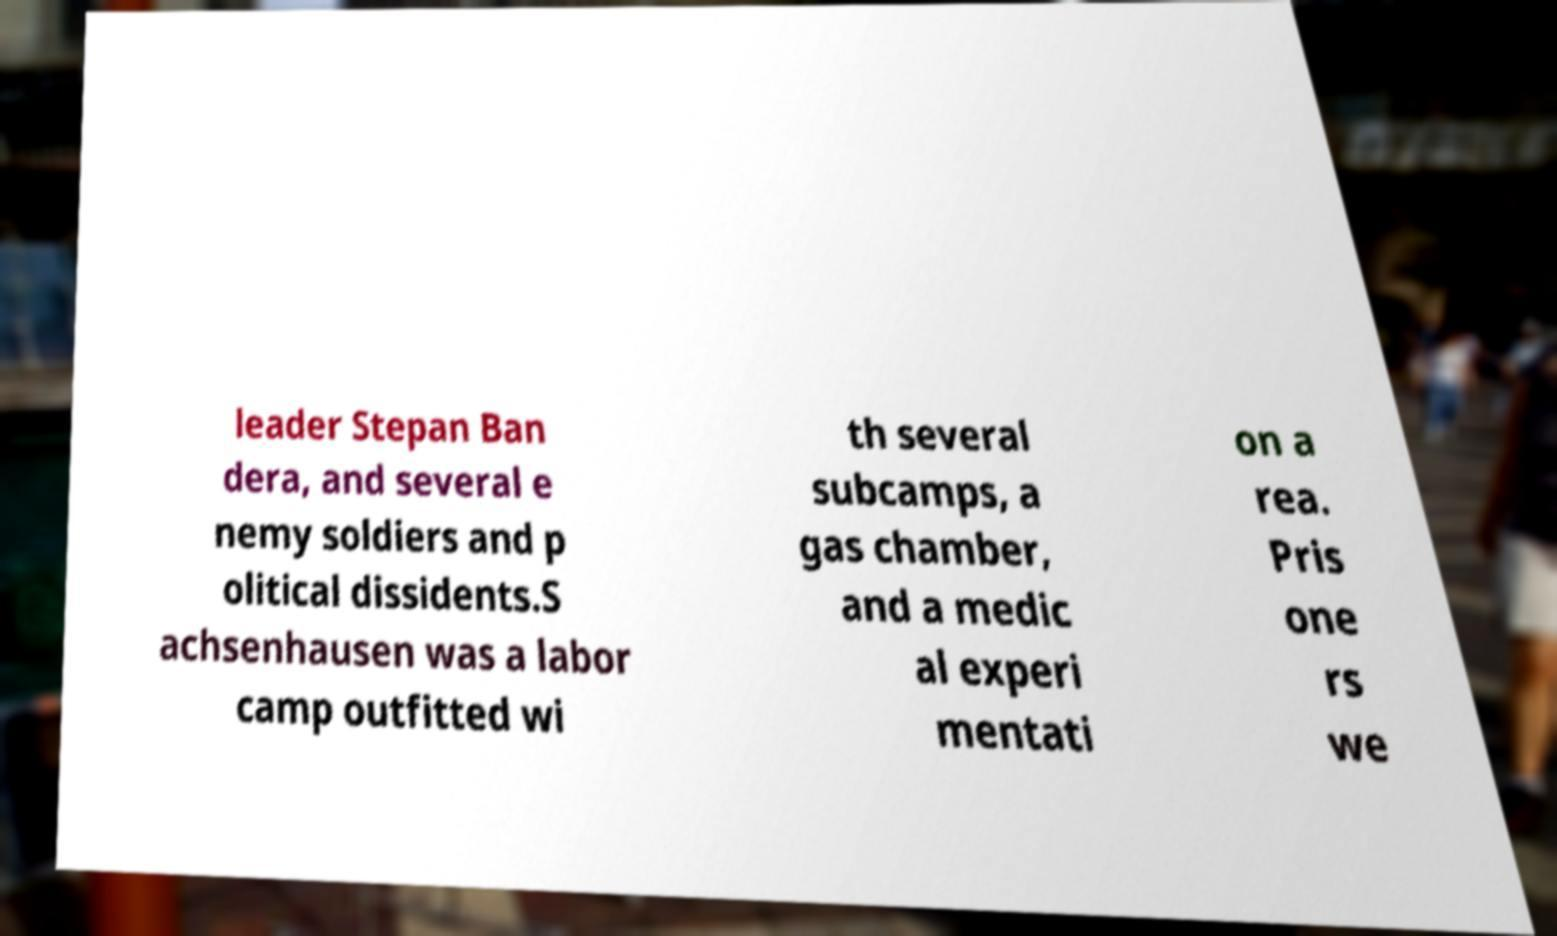There's text embedded in this image that I need extracted. Can you transcribe it verbatim? leader Stepan Ban dera, and several e nemy soldiers and p olitical dissidents.S achsenhausen was a labor camp outfitted wi th several subcamps, a gas chamber, and a medic al experi mentati on a rea. Pris one rs we 